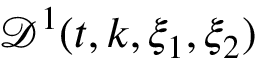<formula> <loc_0><loc_0><loc_500><loc_500>\mathcal { D } ^ { 1 } ( t , k , \xi _ { 1 } , \xi _ { 2 } )</formula> 